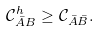<formula> <loc_0><loc_0><loc_500><loc_500>\mathcal { C } ^ { h } _ { \bar { A } B } \geq \mathcal { C } _ { \bar { A } \bar { B } } .</formula> 